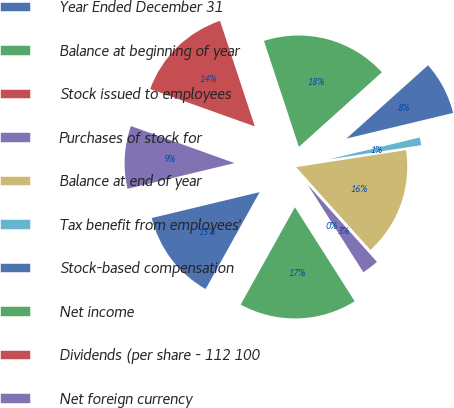Convert chart. <chart><loc_0><loc_0><loc_500><loc_500><pie_chart><fcel>Year Ended December 31<fcel>Balance at beginning of year<fcel>Stock issued to employees<fcel>Purchases of stock for<fcel>Balance at end of year<fcel>Tax benefit from employees'<fcel>Stock-based compensation<fcel>Net income<fcel>Dividends (per share - 112 100<fcel>Net foreign currency<nl><fcel>13.16%<fcel>17.1%<fcel>0.0%<fcel>2.63%<fcel>15.79%<fcel>1.32%<fcel>7.9%<fcel>18.42%<fcel>14.47%<fcel>9.21%<nl></chart> 